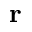<formula> <loc_0><loc_0><loc_500><loc_500>r</formula> 